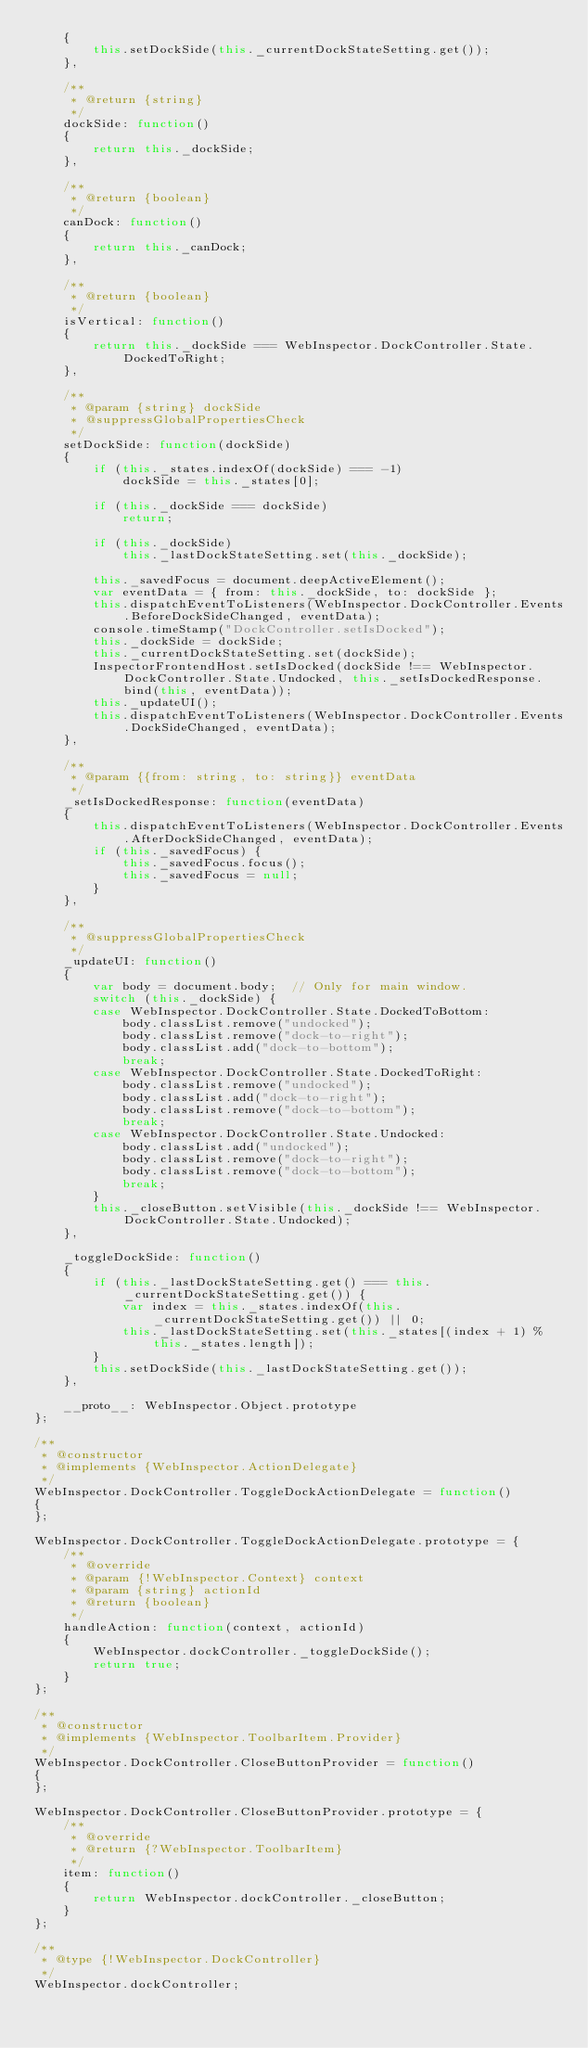<code> <loc_0><loc_0><loc_500><loc_500><_JavaScript_>    {
        this.setDockSide(this._currentDockStateSetting.get());
    },

    /**
     * @return {string}
     */
    dockSide: function()
    {
        return this._dockSide;
    },

    /**
     * @return {boolean}
     */
    canDock: function()
    {
        return this._canDock;
    },

    /**
     * @return {boolean}
     */
    isVertical: function()
    {
        return this._dockSide === WebInspector.DockController.State.DockedToRight;
    },

    /**
     * @param {string} dockSide
     * @suppressGlobalPropertiesCheck
     */
    setDockSide: function(dockSide)
    {
        if (this._states.indexOf(dockSide) === -1)
            dockSide = this._states[0];

        if (this._dockSide === dockSide)
            return;

        if (this._dockSide)
            this._lastDockStateSetting.set(this._dockSide);

        this._savedFocus = document.deepActiveElement();
        var eventData = { from: this._dockSide, to: dockSide };
        this.dispatchEventToListeners(WebInspector.DockController.Events.BeforeDockSideChanged, eventData);
        console.timeStamp("DockController.setIsDocked");
        this._dockSide = dockSide;
        this._currentDockStateSetting.set(dockSide);
        InspectorFrontendHost.setIsDocked(dockSide !== WebInspector.DockController.State.Undocked, this._setIsDockedResponse.bind(this, eventData));
        this._updateUI();
        this.dispatchEventToListeners(WebInspector.DockController.Events.DockSideChanged, eventData);
    },

    /**
     * @param {{from: string, to: string}} eventData
     */
    _setIsDockedResponse: function(eventData)
    {
        this.dispatchEventToListeners(WebInspector.DockController.Events.AfterDockSideChanged, eventData);
        if (this._savedFocus) {
            this._savedFocus.focus();
            this._savedFocus = null;
        }
    },

    /**
     * @suppressGlobalPropertiesCheck
     */
    _updateUI: function()
    {
        var body = document.body;  // Only for main window.
        switch (this._dockSide) {
        case WebInspector.DockController.State.DockedToBottom:
            body.classList.remove("undocked");
            body.classList.remove("dock-to-right");
            body.classList.add("dock-to-bottom");
            break;
        case WebInspector.DockController.State.DockedToRight:
            body.classList.remove("undocked");
            body.classList.add("dock-to-right");
            body.classList.remove("dock-to-bottom");
            break;
        case WebInspector.DockController.State.Undocked:
            body.classList.add("undocked");
            body.classList.remove("dock-to-right");
            body.classList.remove("dock-to-bottom");
            break;
        }
        this._closeButton.setVisible(this._dockSide !== WebInspector.DockController.State.Undocked);
    },

    _toggleDockSide: function()
    {
        if (this._lastDockStateSetting.get() === this._currentDockStateSetting.get()) {
            var index = this._states.indexOf(this._currentDockStateSetting.get()) || 0;
            this._lastDockStateSetting.set(this._states[(index + 1) % this._states.length]);
        }
        this.setDockSide(this._lastDockStateSetting.get());
    },

    __proto__: WebInspector.Object.prototype
};

/**
 * @constructor
 * @implements {WebInspector.ActionDelegate}
 */
WebInspector.DockController.ToggleDockActionDelegate = function()
{
};

WebInspector.DockController.ToggleDockActionDelegate.prototype = {
    /**
     * @override
     * @param {!WebInspector.Context} context
     * @param {string} actionId
     * @return {boolean}
     */
    handleAction: function(context, actionId)
    {
        WebInspector.dockController._toggleDockSide();
        return true;
    }
};

/**
 * @constructor
 * @implements {WebInspector.ToolbarItem.Provider}
 */
WebInspector.DockController.CloseButtonProvider = function()
{
};

WebInspector.DockController.CloseButtonProvider.prototype = {
    /**
     * @override
     * @return {?WebInspector.ToolbarItem}
     */
    item: function()
    {
        return WebInspector.dockController._closeButton;
    }
};

/**
 * @type {!WebInspector.DockController}
 */
WebInspector.dockController;
</code> 